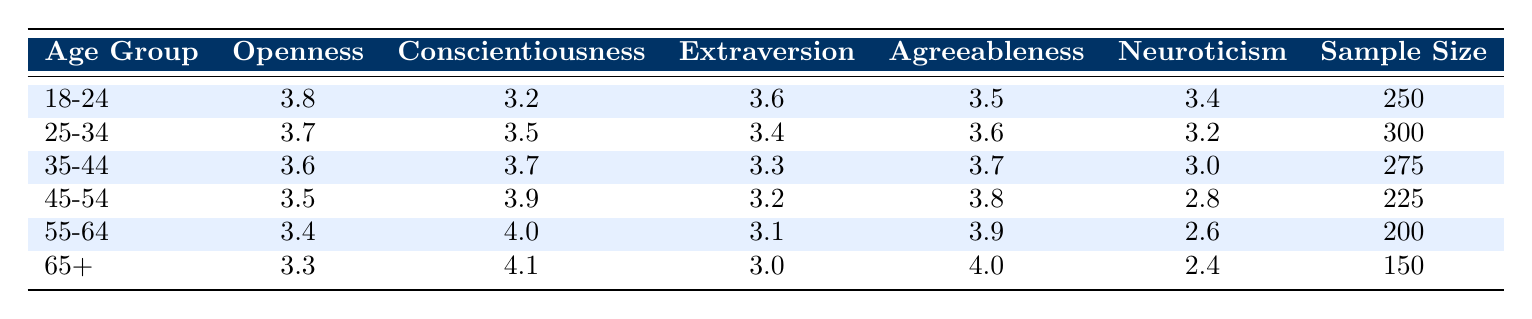What is the openness score for the age group 45-54? The table lists the score for openness in the row corresponding to the age group 45-54, which is 3.5.
Answer: 3.5 Which age group has the highest score in conscientiousness? By scanning the conscientiousness scores in the table, the age group 65+ has the highest score of 4.1.
Answer: 65+ What is the sample size for the age group 35-44? The sample size for the age group 35-44 can be found in the corresponding row of the table, which shows a sample size of 275.
Answer: 275 Is the neuroticism score for the age group 55-64 less than that of the age group 25-34? The table shows a neuroticism score of 2.6 for 55-64 and 3.2 for 25-34. Since 2.6 is less than 3.2, the statement is true.
Answer: Yes What is the difference in extraversion scores between the age groups 18-24 and 55-64? The extraversion score for age group 18-24 is 3.6 and for age group 55-64 is 3.1. The difference is calculated as 3.6 - 3.1 = 0.5.
Answer: 0.5 Which age group shows the highest agreeableness score? Looking through the agreeableness scores, the age group 65+ has the highest score of 4.0.
Answer: 65+ What is the average openness score across all age groups? The openness scores are 3.8, 3.7, 3.6, 3.5, 3.4, and 3.3. The sum is 3.8 + 3.7 + 3.6 + 3.5 + 3.4 + 3.3 = 18.3, and there are 6 age groups. To find the average, divide 18.3 by 6, which results in 3.05.
Answer: 3.05 If we consider only the age groups under 35, which trait has the lowest score? The relevant age groups are 18-24 and 25-34. The scores for conscientiousness in these groups are 3.2 and 3.5 respectively. The lowest score of those is 3.2 for the 18-24 group.
Answer: Conscientiousness What trend is observed in neuroticism scores as age increases? By evaluating the neuroticism scores across the age groups, they decrease from 3.4 (18-24) to 2.4 (65+). This indicates a downward trend in neuroticism as age increases.
Answer: Decreasing trend What is the composite score of openness and agreeableness for the age group 45-54? The openness score for age group 45-54 is 3.5 and the agreeableness score is 3.8. The composite score combines these two: 3.5 + 3.8 = 7.3.
Answer: 7.3 